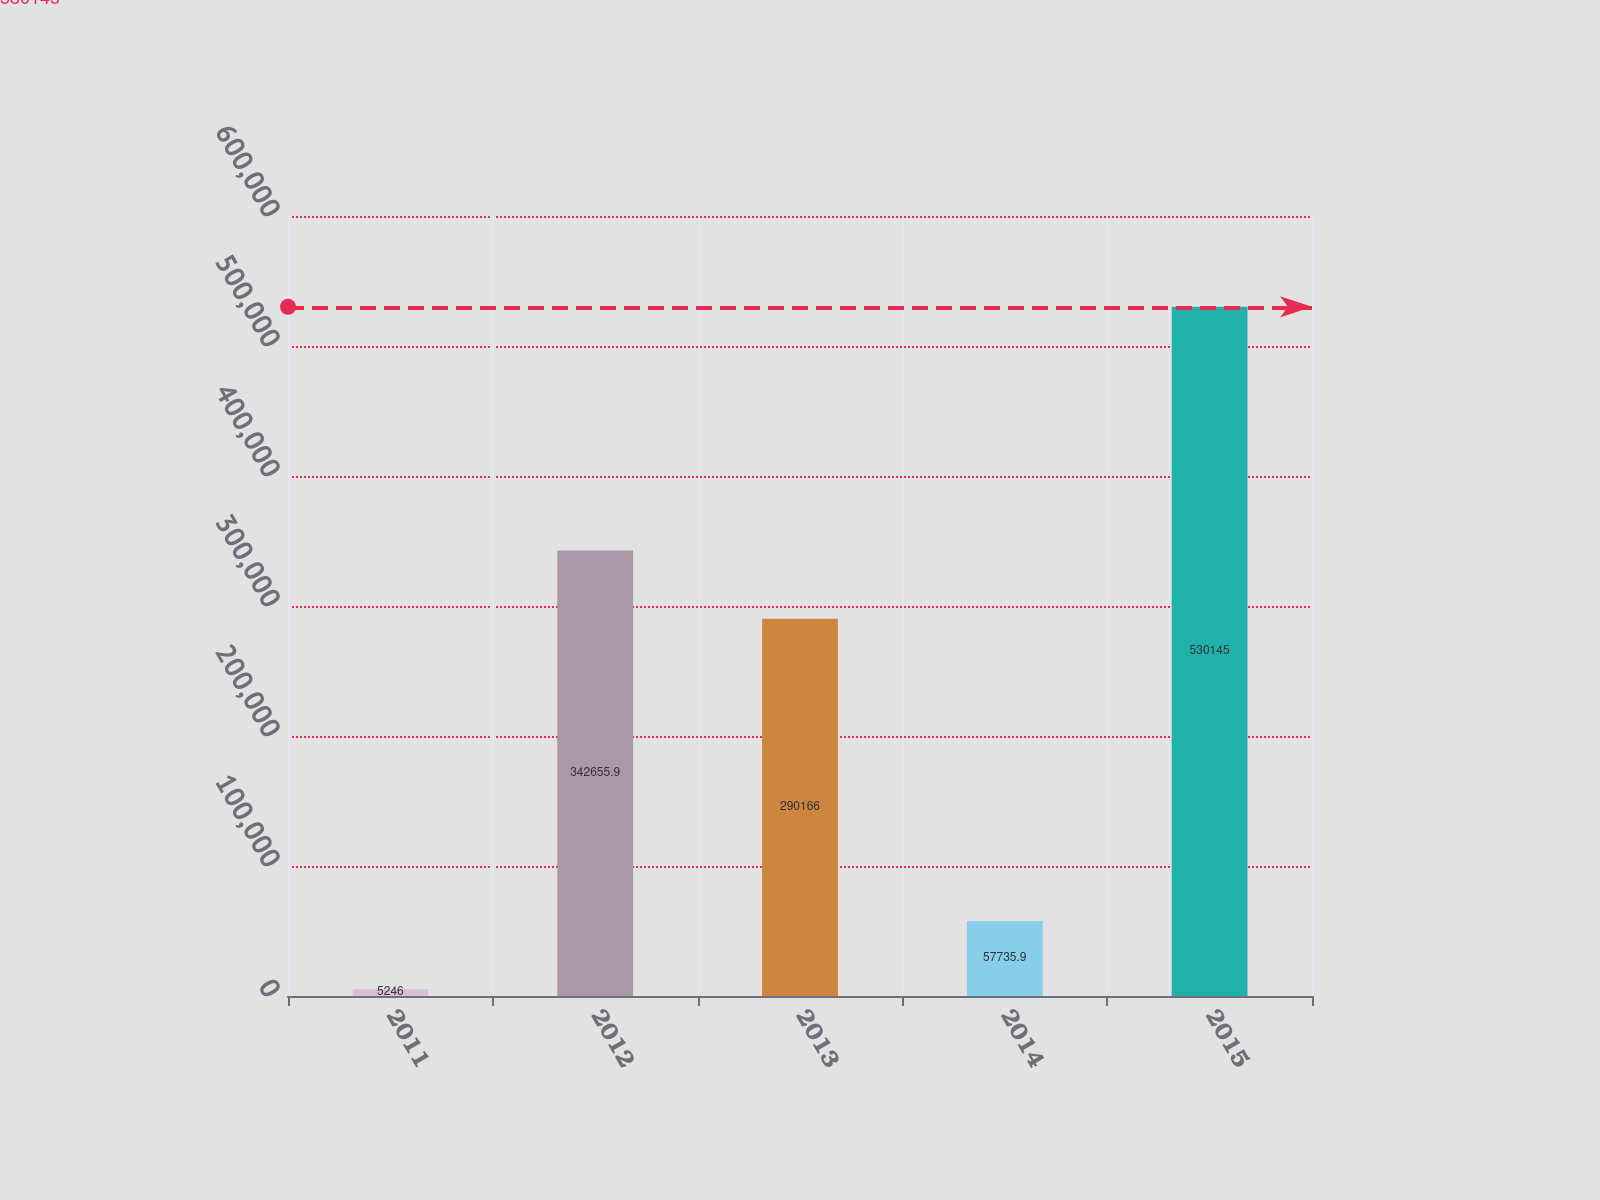Convert chart to OTSL. <chart><loc_0><loc_0><loc_500><loc_500><bar_chart><fcel>2011<fcel>2012<fcel>2013<fcel>2014<fcel>2015<nl><fcel>5246<fcel>342656<fcel>290166<fcel>57735.9<fcel>530145<nl></chart> 